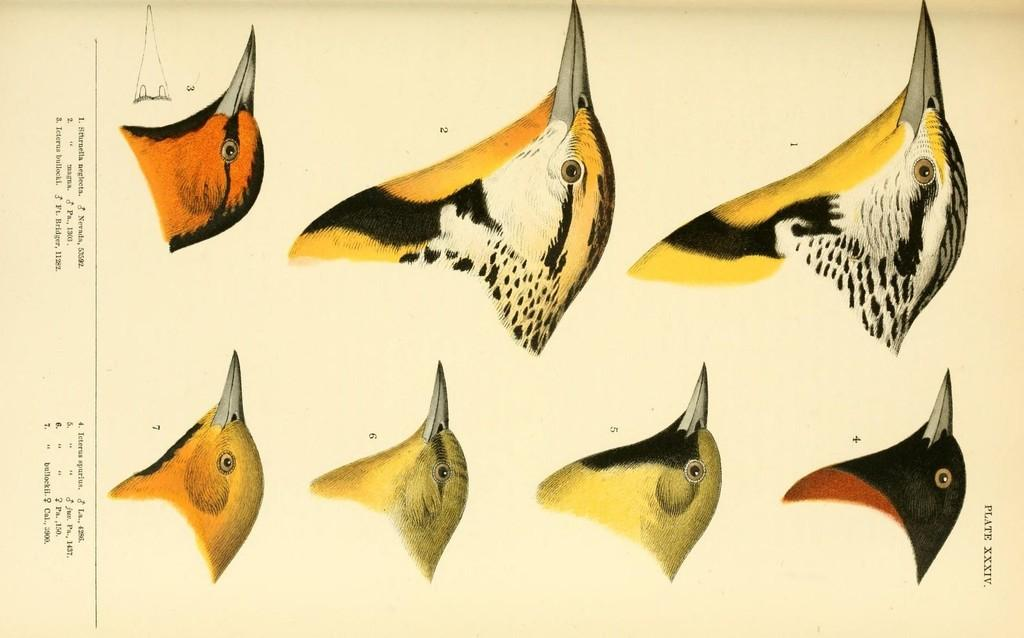How many birds are depicted in the drawing? There are seven birds in the drawing. Where can text be found in the drawing? Text can be found on the left side and in the bottom right of the drawing. What type of dinner is being served in the drawing? There is no dinner depicted in the drawing; it features seven birds and text. How many boats are visible in the drawing? There are no boats present in the drawing. 